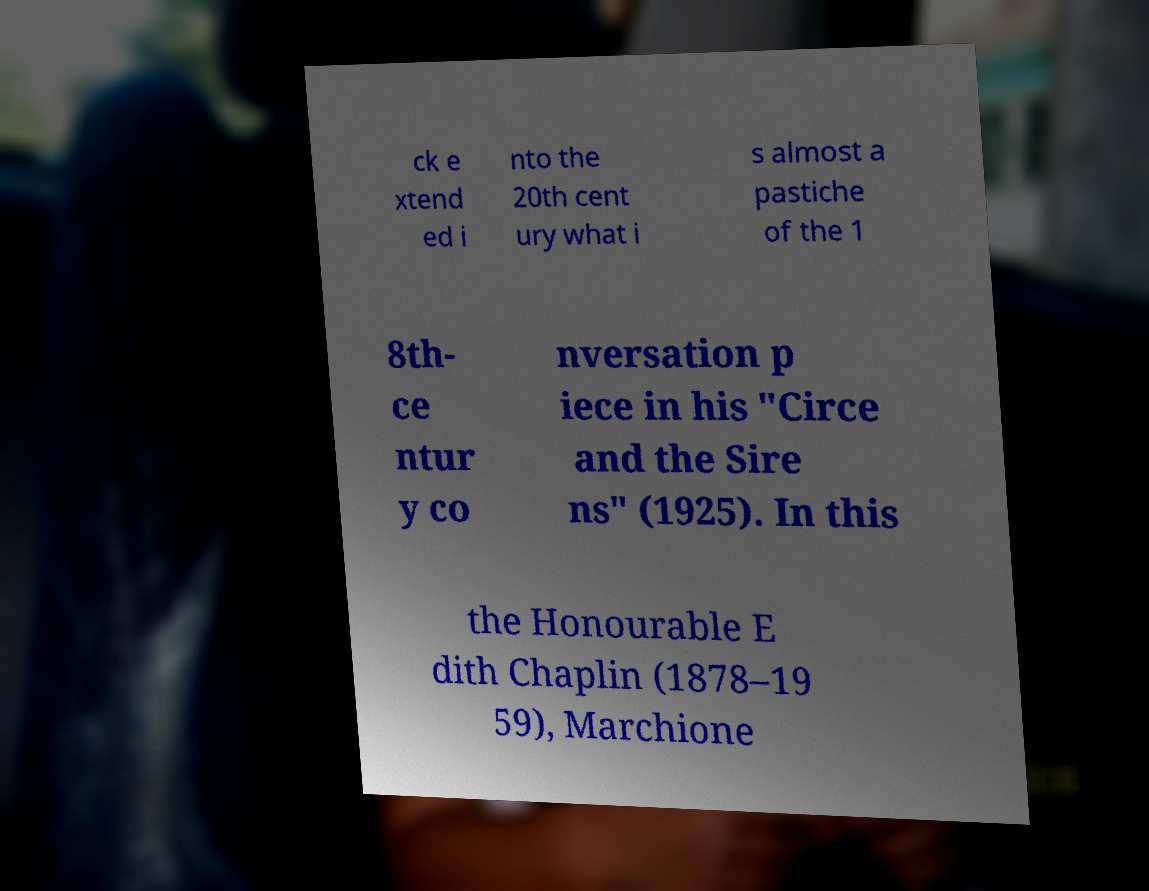Please read and relay the text visible in this image. What does it say? ck e xtend ed i nto the 20th cent ury what i s almost a pastiche of the 1 8th- ce ntur y co nversation p iece in his "Circe and the Sire ns" (1925). In this the Honourable E dith Chaplin (1878–19 59), Marchione 